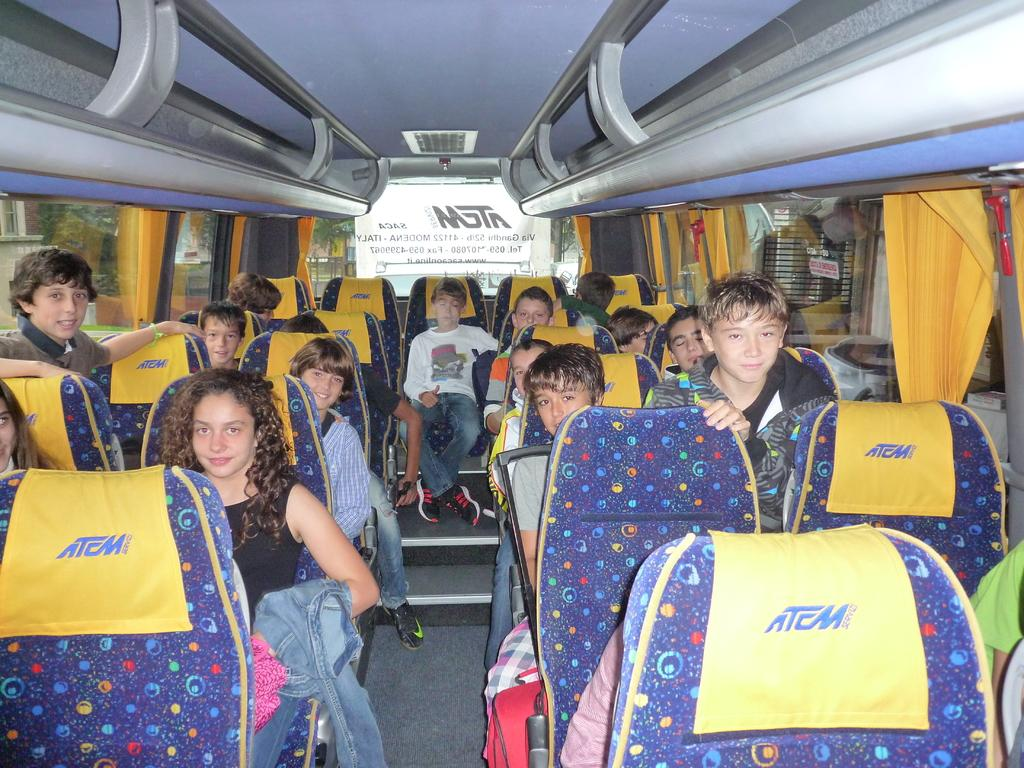What are the people in the image doing? The people in the image are sitting on seats. What can be seen through the windows in the image? The details of what can be seen through the windows are not provided, but windows are visible in the image. What type of window treatment is present in the image? Yellow color curtains are present in the image. What type of flowers are being discussed by the people in the image? There is no indication in the image that the people are discussing flowers, so it cannot be determined from the picture. 